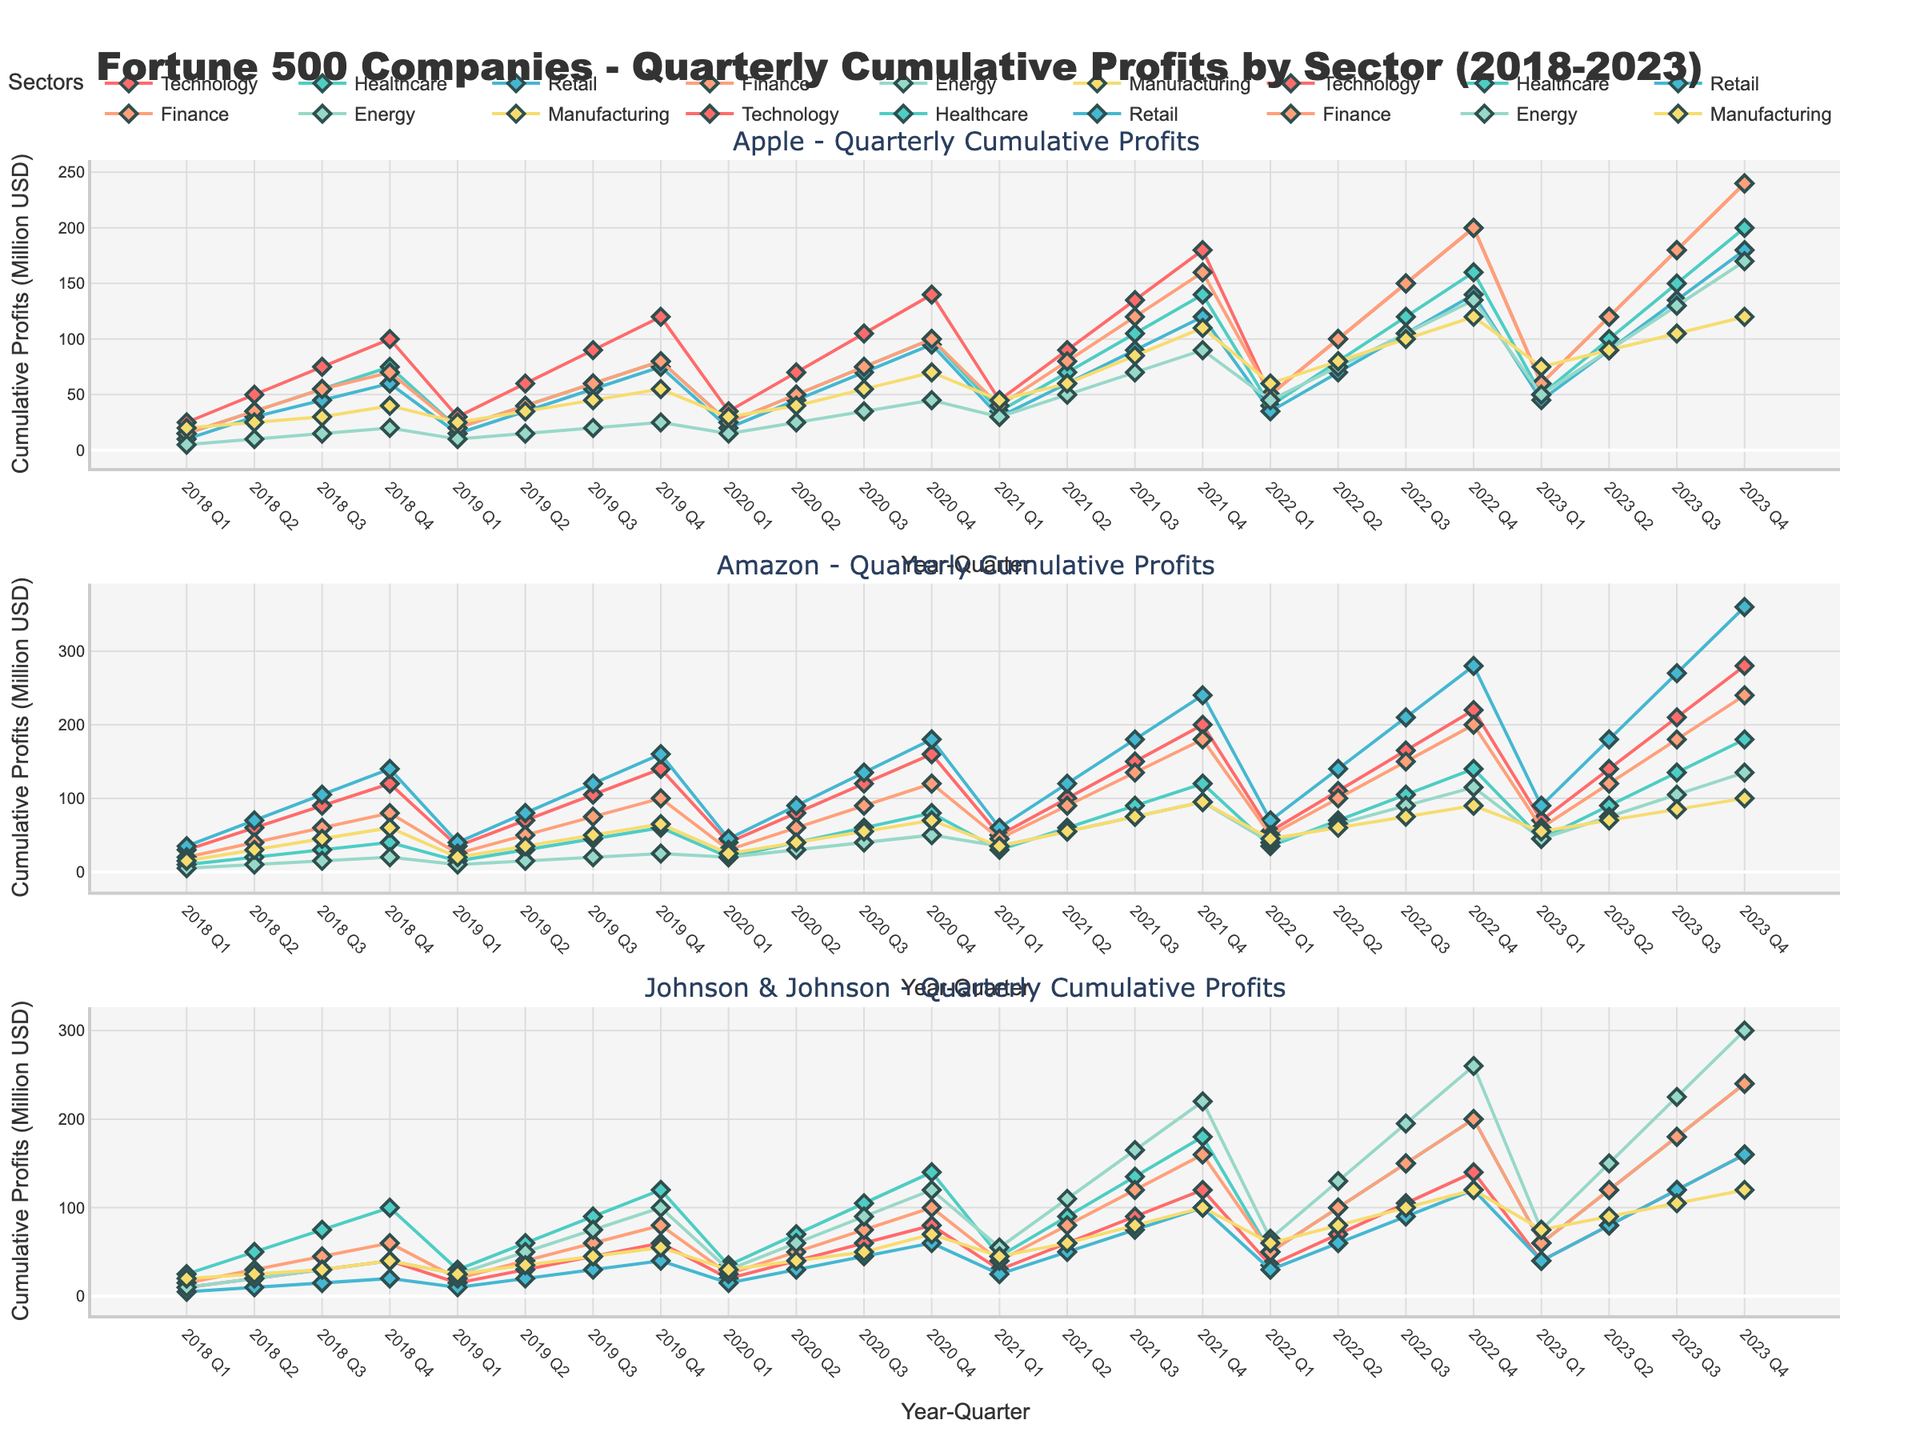What is the title of the figure? The title of a figure is usually found at the top and is indicative of the data being presented. By referring to the figure, we can see that the title is prominently displayed.
Answer: Fortune 500 Companies - Quarterly Cumulative Profits by Sector (2018-2023) How many companies' data are displayed in the plots? The number of companies can be identified by counting the subplot titles or the number of distinct company names in the legend. From the subplot titles, we can count the total number of companies displayed.
Answer: 3 Which sector has used color red for its line plot? The colors representing each sector can be distinguished by looking at the legend of the figure. The red color line represents the 'Technology' sector in the legend.
Answer: Technology For Apple in 2021 Q4, what is the cumulative profit in the Finance sector? To find this, locate the subplot for Apple, then navigate to the Q4 data point for 2021. Identify the line corresponding to the Finance sector and read the y-value.
Answer: 160 What is the difference in Technology sector profits between Amazon and Johnson & Johnson in 2023 Q3? First, locate the Q3 data point for 2023 in the subplots for both Amazon and Johnson & Johnson. Identify the Technology sector lines and note their y-values. Subtract the y-value for Johnson & Johnson from Amazon.
Answer: 90 Which company saw the highest quarterly cumulative profits in the Retail sector in 2022 Q4? Locate the Retail sector lines for all companies and check the 2022 Q4 data points. Compare the y-values across the companies, and the one with the highest value is the answer.
Answer: Amazon For the Energy sector, what is the cumulative profit across all quarters from 2020 for Johnson & Johnson? Identify the subplot for Johnson & Johnson and locate the data points for the Energy sector from Q1 to Q4 in 2020. Sum the y-values of these four data points.
Answer: 300 Between Apple and Amazon, which company experienced a larger increase in cumulative profits in the Technology sector from 2018 Q1 to 2023 Q4? Calculate the increase in cumulative profits from 2018 Q1 to 2023 Q4 for both companies in the Technology sector by finding the difference in y-values at these data points for both subplots. Compare the two results.
Answer: Amazon In which sector did all three companies experience a steady increase in cumulative profits over the five years? Analyze the trend lines for all three companies across the six sectors, looking for a sector where all lines show a consistent upwards trend without dips.
Answer: Healthcare 